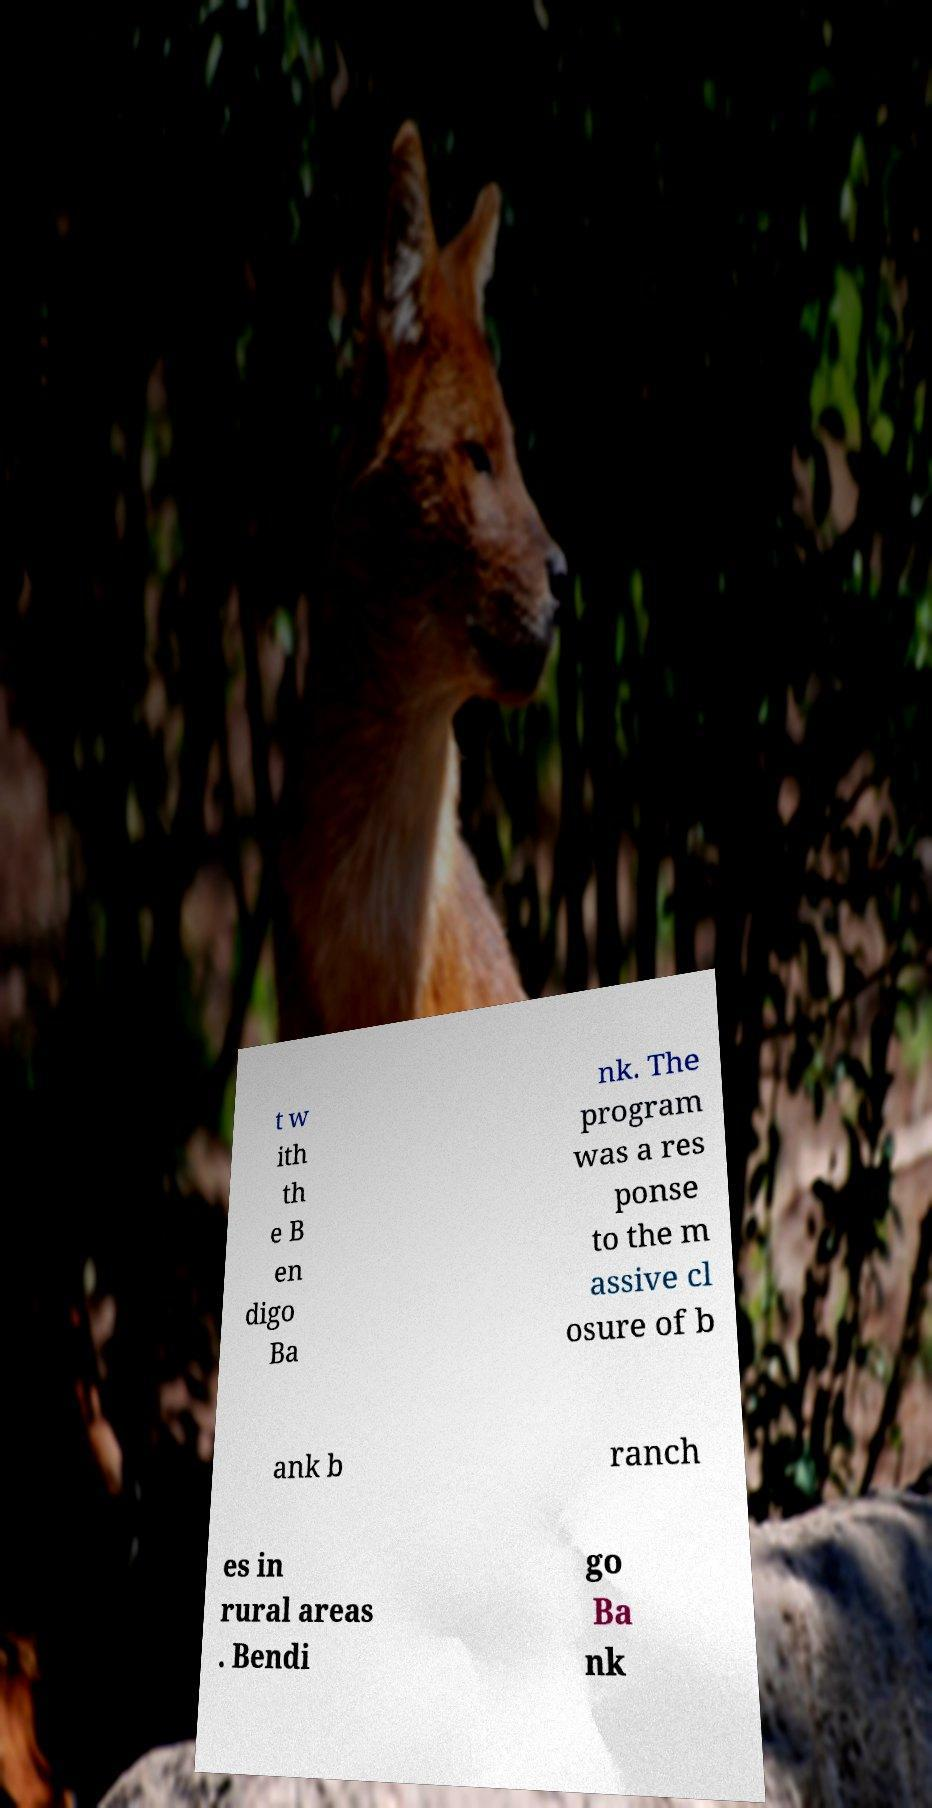Can you read and provide the text displayed in the image?This photo seems to have some interesting text. Can you extract and type it out for me? t w ith th e B en digo Ba nk. The program was a res ponse to the m assive cl osure of b ank b ranch es in rural areas . Bendi go Ba nk 